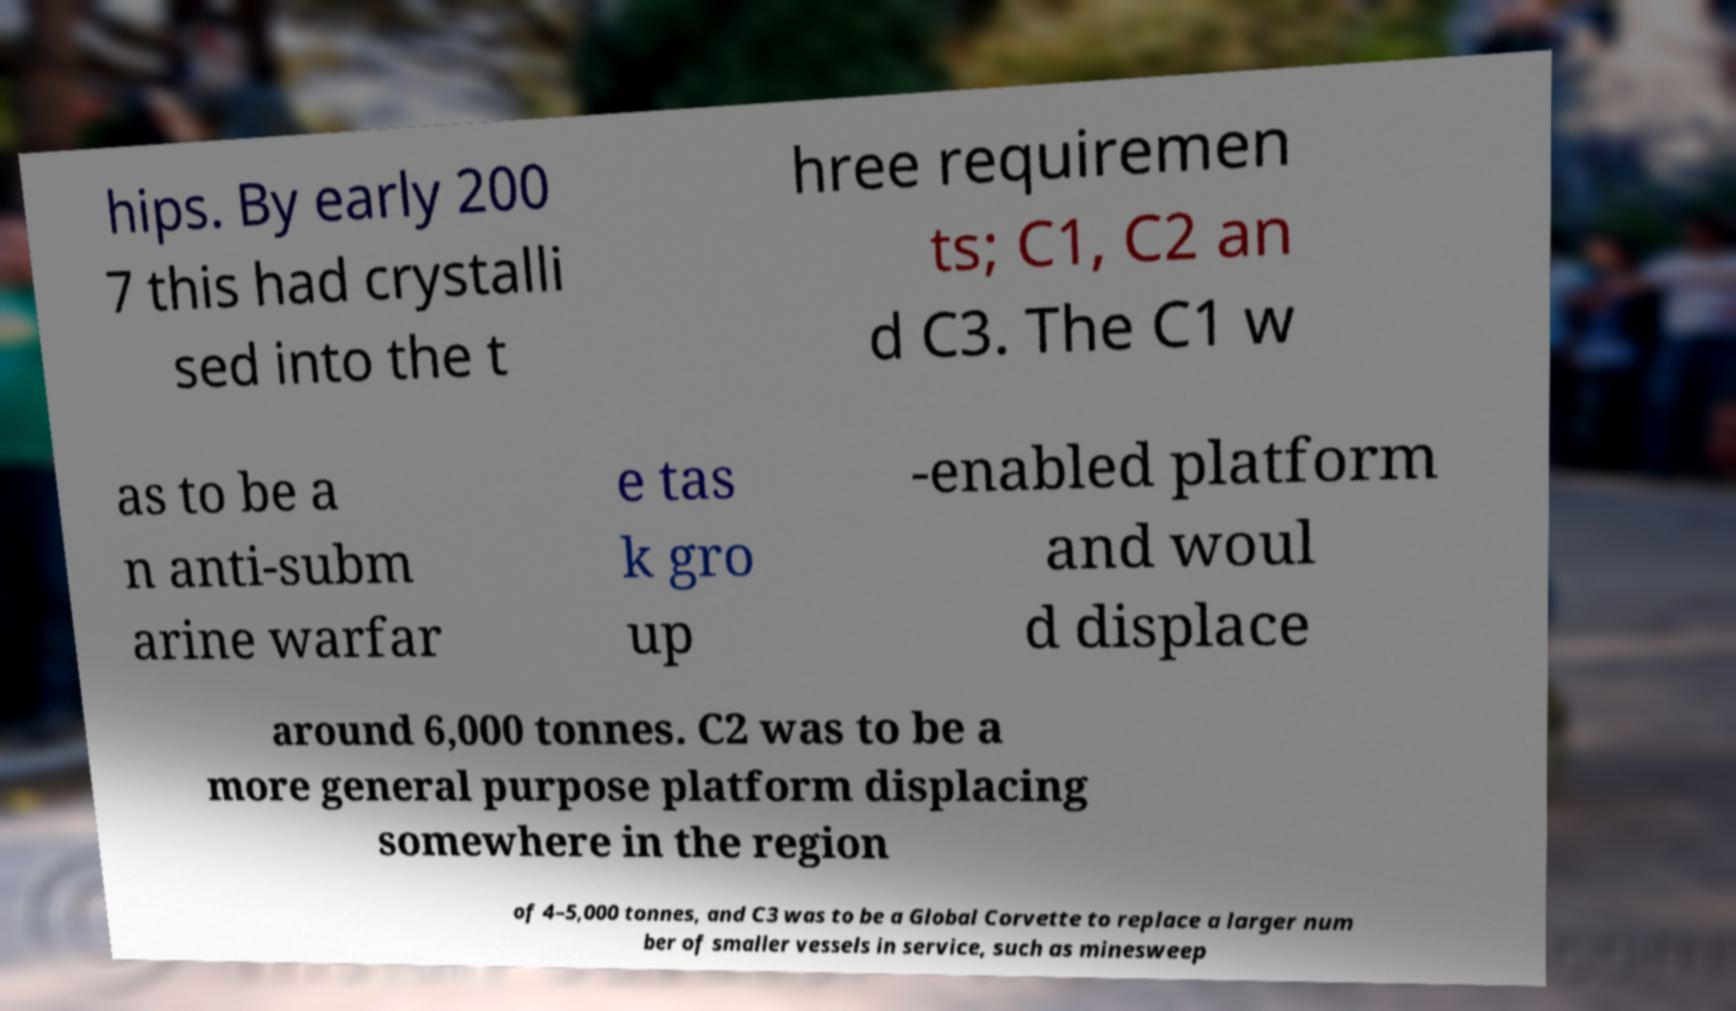Can you accurately transcribe the text from the provided image for me? hips. By early 200 7 this had crystalli sed into the t hree requiremen ts; C1, C2 an d C3. The C1 w as to be a n anti-subm arine warfar e tas k gro up -enabled platform and woul d displace around 6,000 tonnes. C2 was to be a more general purpose platform displacing somewhere in the region of 4–5,000 tonnes, and C3 was to be a Global Corvette to replace a larger num ber of smaller vessels in service, such as minesweep 